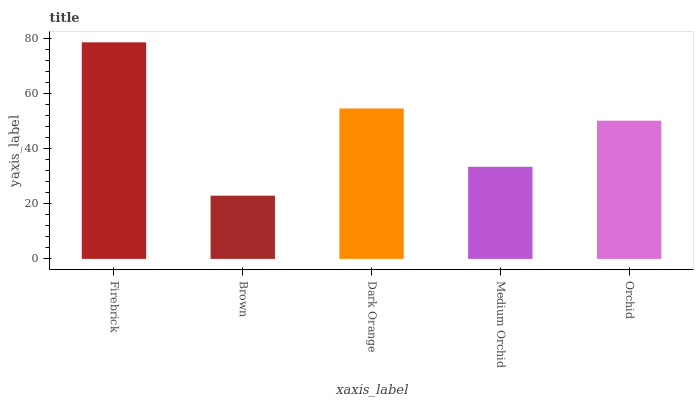Is Brown the minimum?
Answer yes or no. Yes. Is Firebrick the maximum?
Answer yes or no. Yes. Is Dark Orange the minimum?
Answer yes or no. No. Is Dark Orange the maximum?
Answer yes or no. No. Is Dark Orange greater than Brown?
Answer yes or no. Yes. Is Brown less than Dark Orange?
Answer yes or no. Yes. Is Brown greater than Dark Orange?
Answer yes or no. No. Is Dark Orange less than Brown?
Answer yes or no. No. Is Orchid the high median?
Answer yes or no. Yes. Is Orchid the low median?
Answer yes or no. Yes. Is Firebrick the high median?
Answer yes or no. No. Is Firebrick the low median?
Answer yes or no. No. 